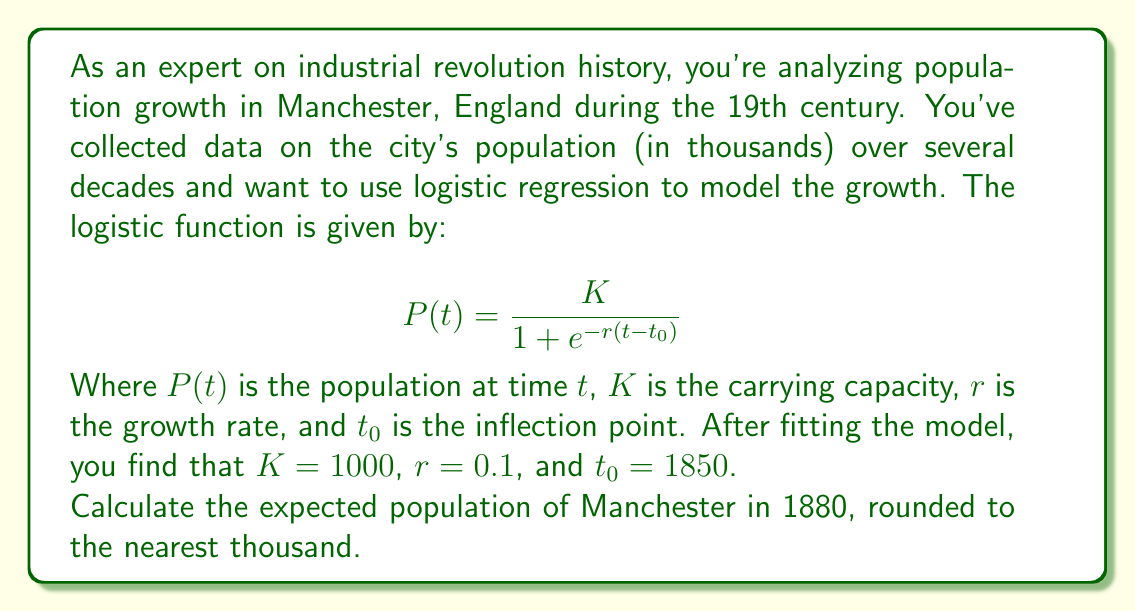Show me your answer to this math problem. To solve this problem, we'll follow these steps:

1) We have the logistic function:
   $$ P(t) = \frac{K}{1 + e^{-r(t-t_0)}} $$

2) We're given the following parameters:
   $K = 1000$ (carrying capacity)
   $r = 0.1$ (growth rate)
   $t_0 = 1850$ (inflection point)
   $t = 1880$ (the year we're calculating for)

3) Let's substitute these values into the equation:
   $$ P(1880) = \frac{1000}{1 + e^{-0.1(1880-1850)}} $$

4) Simplify the exponent:
   $$ P(1880) = \frac{1000}{1 + e^{-0.1(30)}} = \frac{1000}{1 + e^{-3}} $$

5) Calculate $e^{-3}$:
   $e^{-3} \approx 0.0498$

6) Substitute this value:
   $$ P(1880) = \frac{1000}{1 + 0.0498} = \frac{1000}{1.0498} $$

7) Divide:
   $P(1880) \approx 952.56$

8) Rounding to the nearest thousand:
   $P(1880) \approx 953$ thousand

Therefore, the expected population of Manchester in 1880, according to this logistic regression model, is approximately 953,000 people.
Answer: 953,000 